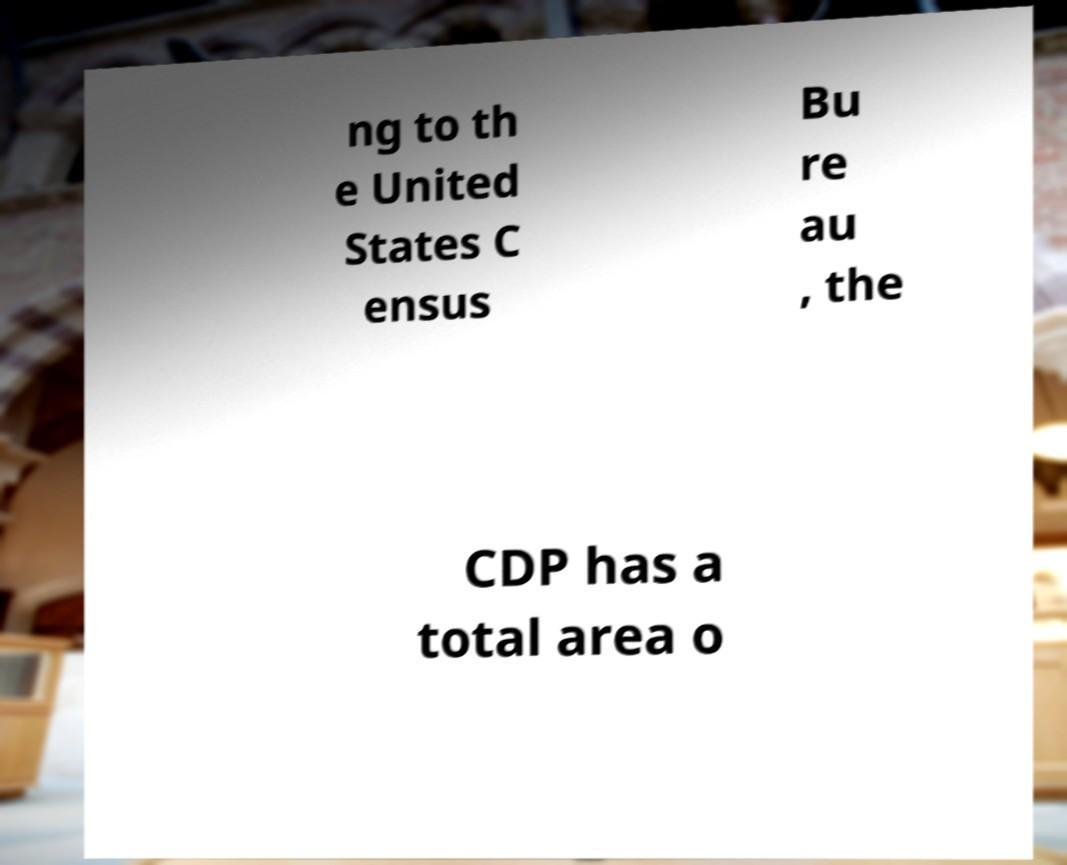What messages or text are displayed in this image? I need them in a readable, typed format. ng to th e United States C ensus Bu re au , the CDP has a total area o 